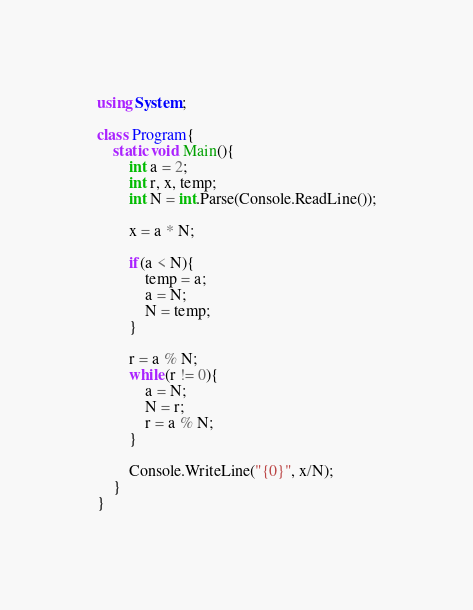Convert code to text. <code><loc_0><loc_0><loc_500><loc_500><_C#_>using System;

class Program{
    static void Main(){
        int a = 2;
        int r, x, temp;
        int N = int.Parse(Console.ReadLine());
    
        x = a * N;

        if(a < N){
            temp = a;
            a = N;
            N = temp;
        }

        r = a % N;
        while(r != 0){
            a = N;
            N = r;
            r = a % N;
        }

        Console.WriteLine("{0}", x/N);
    }
}</code> 